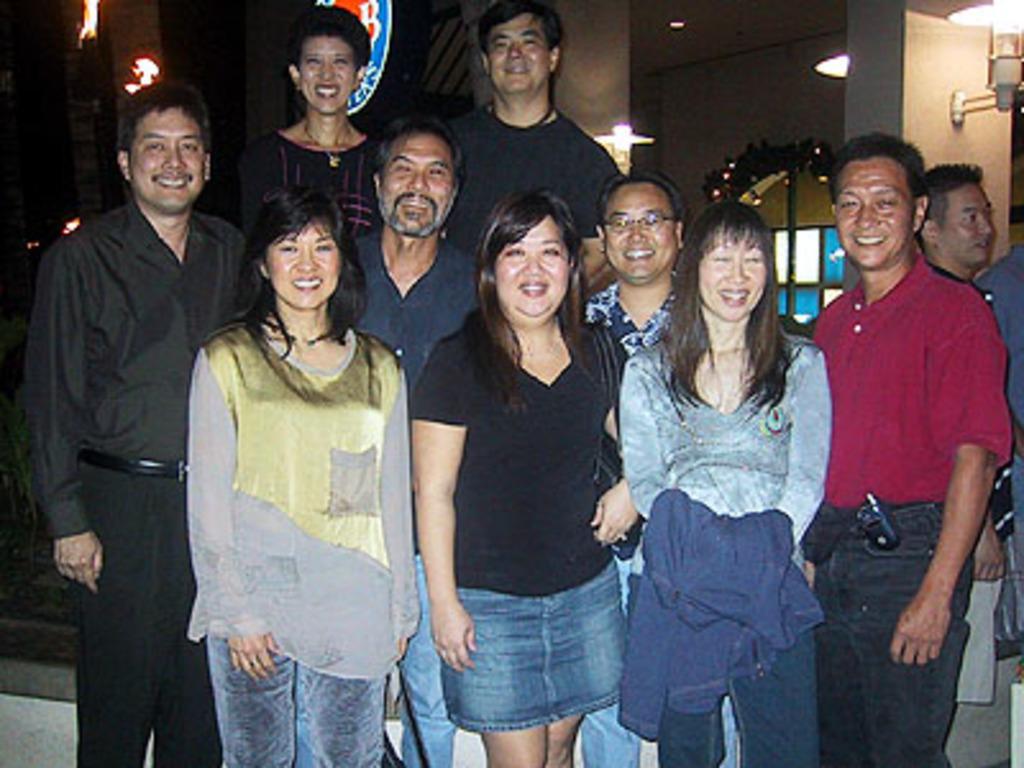Please provide a concise description of this image. In this image we can see persons standing and smiling. In the background we can see walls, windows, doors and electric lights. 